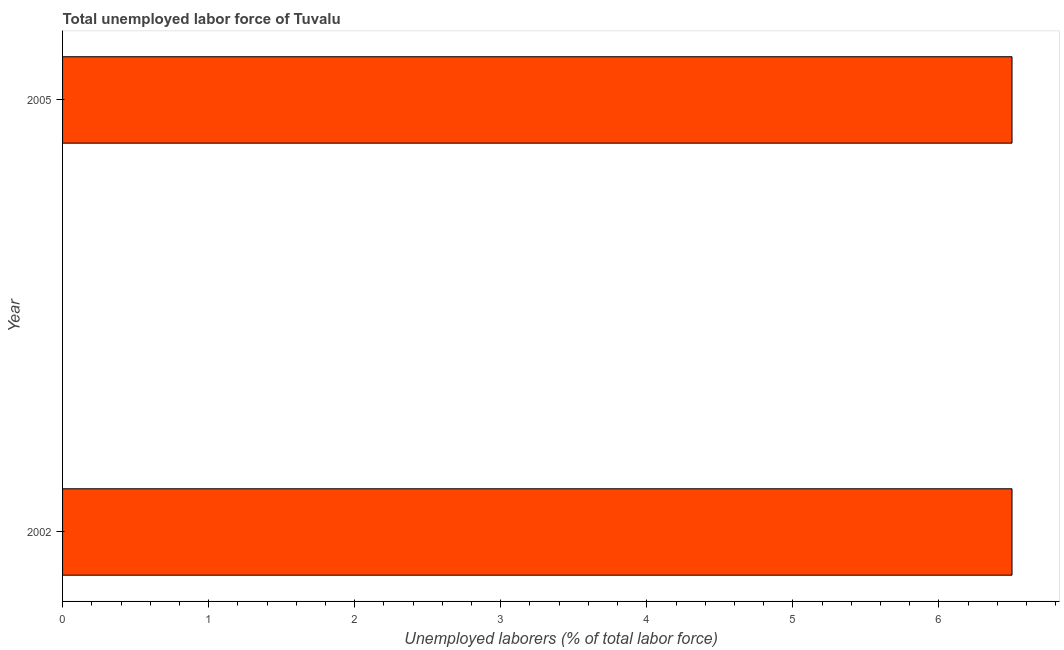Does the graph contain grids?
Provide a short and direct response. No. What is the title of the graph?
Offer a terse response. Total unemployed labor force of Tuvalu. What is the label or title of the X-axis?
Offer a terse response. Unemployed laborers (% of total labor force). What is the label or title of the Y-axis?
Offer a very short reply. Year. Across all years, what is the minimum total unemployed labour force?
Offer a very short reply. 6.5. In which year was the total unemployed labour force maximum?
Provide a short and direct response. 2002. What is the sum of the total unemployed labour force?
Ensure brevity in your answer.  13. What is the difference between the total unemployed labour force in 2002 and 2005?
Provide a succinct answer. 0. What is the median total unemployed labour force?
Your answer should be compact. 6.5. Do a majority of the years between 2002 and 2005 (inclusive) have total unemployed labour force greater than 1.8 %?
Your answer should be very brief. Yes. Are all the bars in the graph horizontal?
Provide a succinct answer. Yes. How many years are there in the graph?
Make the answer very short. 2. Are the values on the major ticks of X-axis written in scientific E-notation?
Give a very brief answer. No. What is the difference between the Unemployed laborers (% of total labor force) in 2002 and 2005?
Keep it short and to the point. 0. 